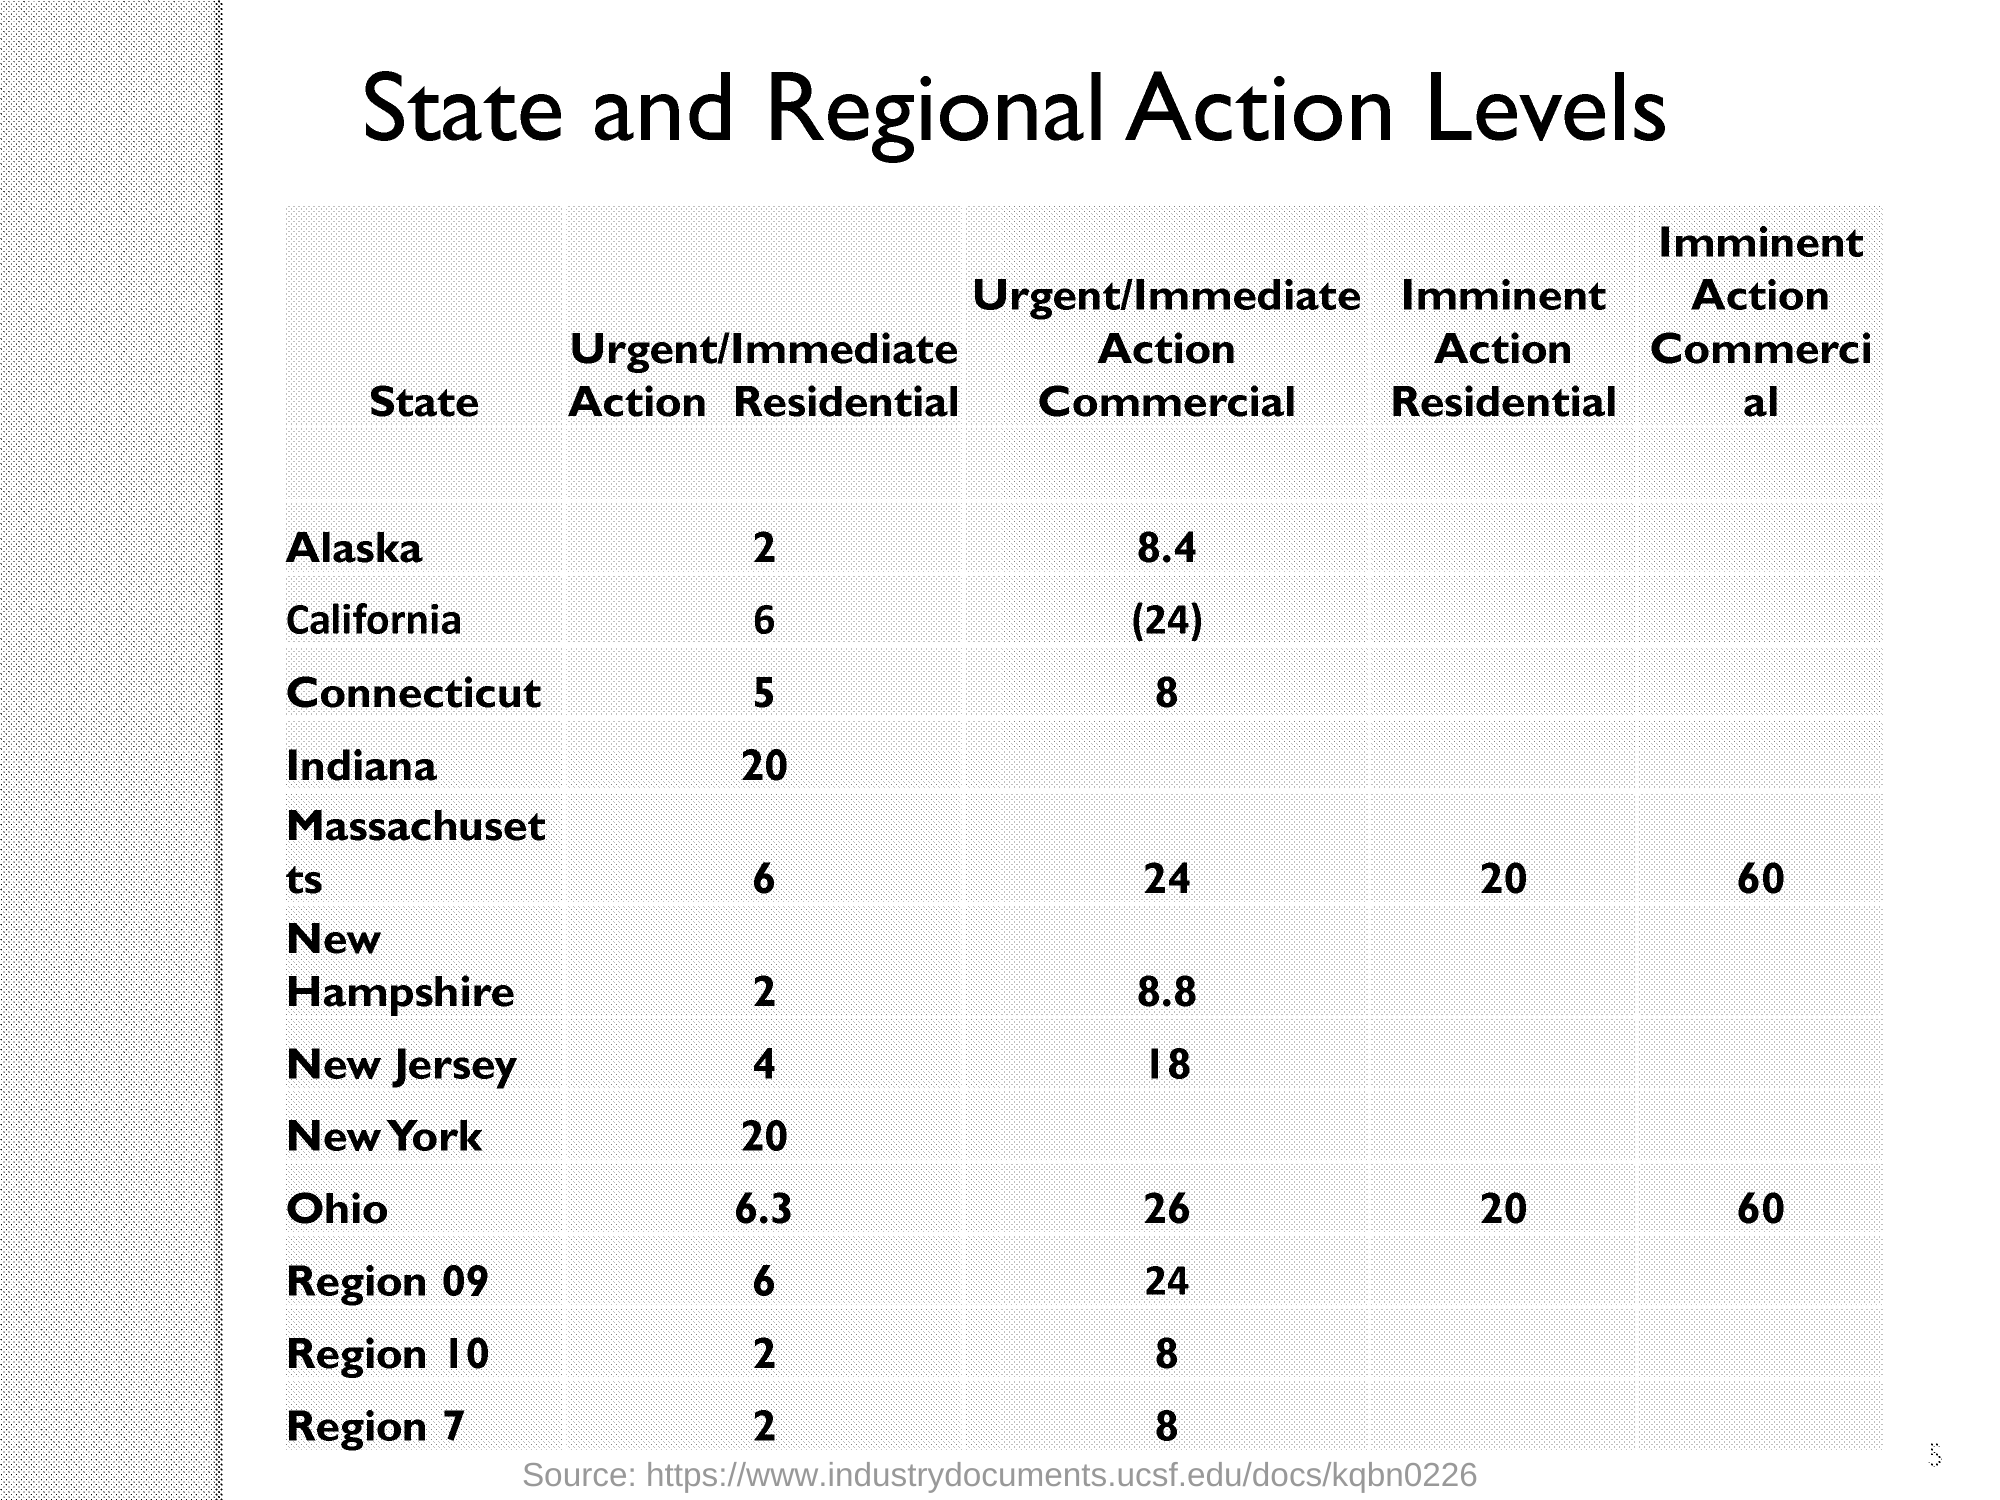What is the Urgent/Immediate Action Commercial of Connecticut?
Offer a very short reply. 8. What is the Imminent Action Residential of Massachusetts ?
Keep it short and to the point. 20. What is the Imminent Action Commercial of Ohio?
Your response must be concise. 60. 